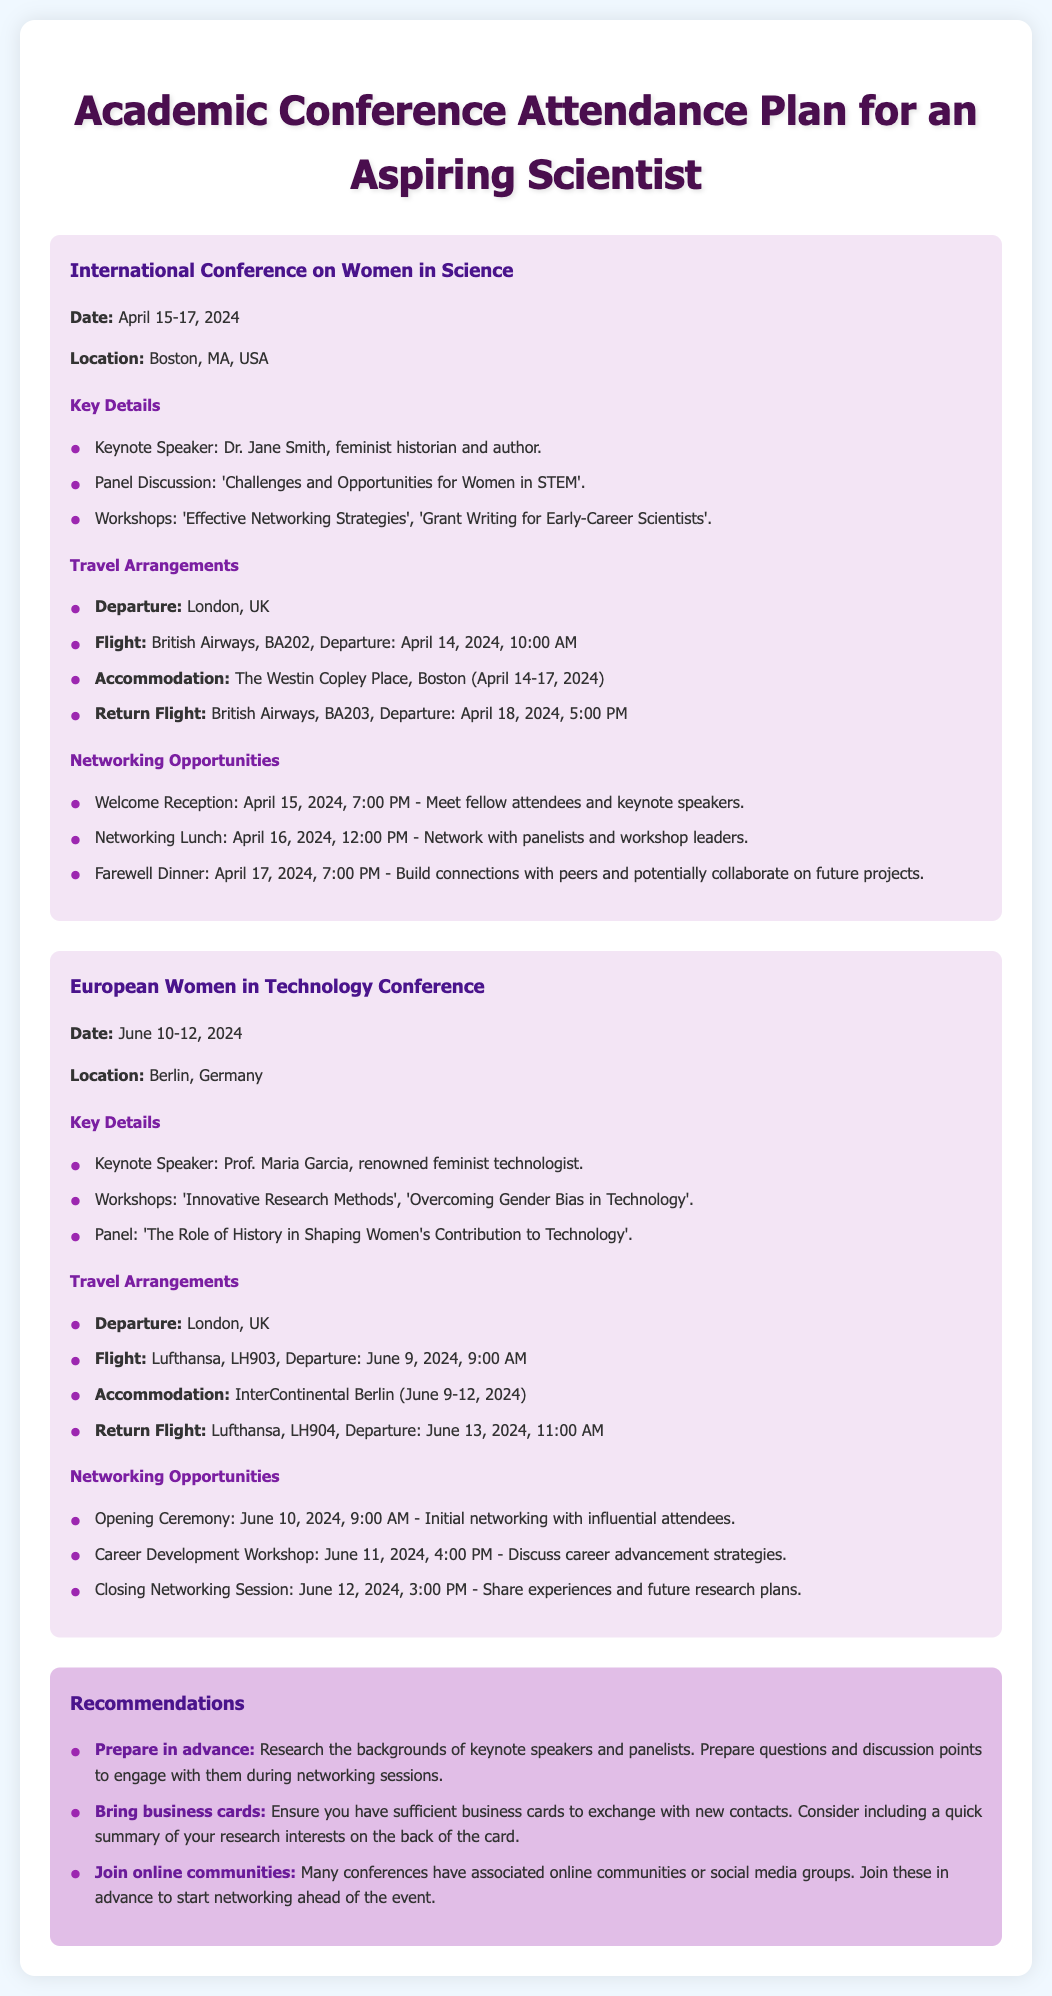What is the date of the International Conference on Women in Science? The date of the conference is specified in the document.
Answer: April 15-17, 2024 Who is the keynote speaker for the European Women in Technology Conference? The document lists the keynote speakers for each conference, including the European Women in Technology Conference.
Answer: Prof. Maria Garcia What city will host the International Conference on Women in Science? The document provides the location for the conference, which is mentioned clearly.
Answer: Boston, MA, USA What is the departure city for both conferences? The document indicates the starting point for travel for both conferences.
Answer: London, UK What time is the return flight from Boston? The return flight time for the International Conference is listed in the travel arrangements section.
Answer: 5:00 PM What networking opportunity occurs on April 16, 2024? The document outlines specific networking events, including dates and times.
Answer: Networking Lunch How many workshops are mentioned for the International Conference on Women in Science? The document includes a list of workshops for the conference.
Answer: Two What is one recommendation for networking before the conference? The recommendations section includes specific advice for networking.
Answer: Join online communities When is the opening ceremony for the European Women in Technology Conference? The timing of key events is specified in the networking section.
Answer: June 10, 2024, 9:00 AM 